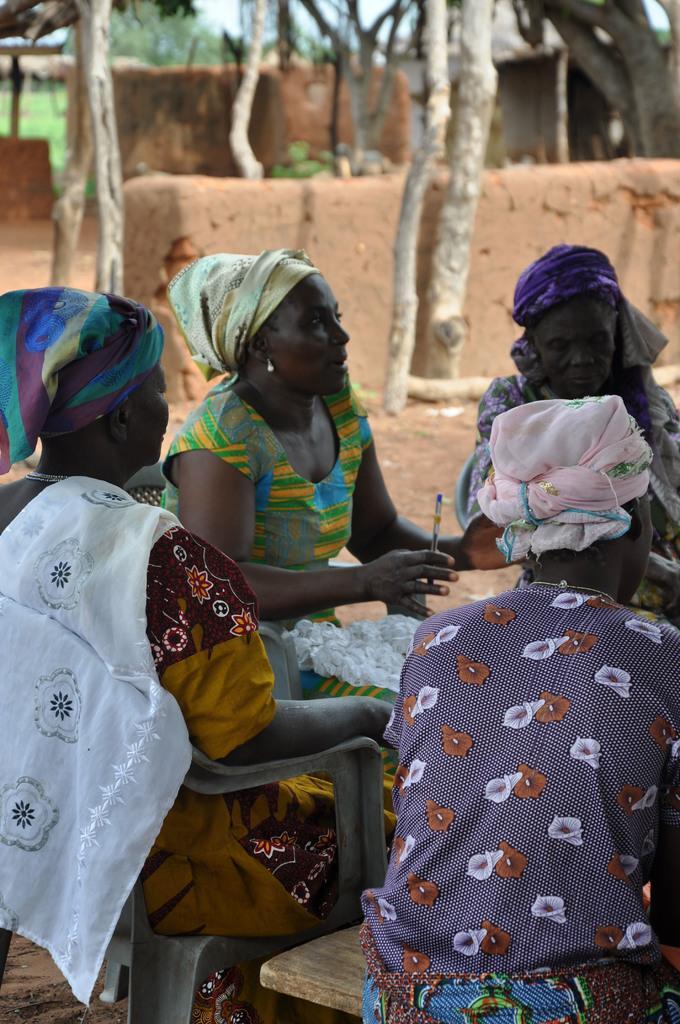How would you summarize this image in a sentence or two? This image is clicked outside. There are some people sitting in the middle. There are trees at the top. 